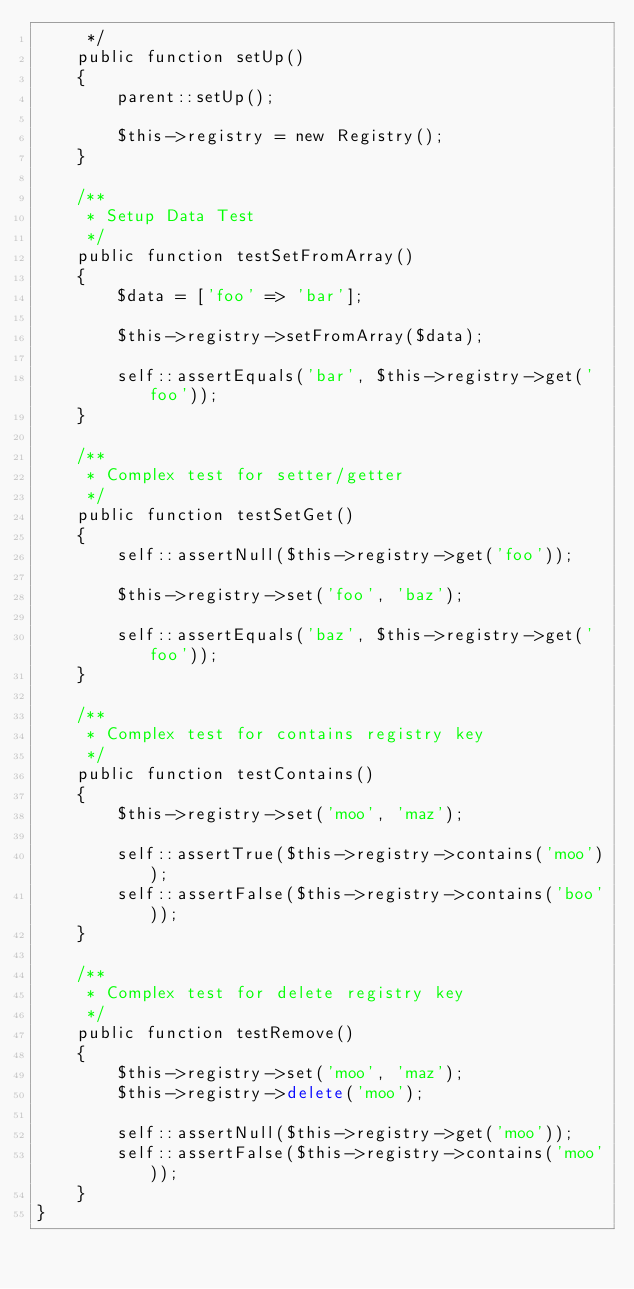Convert code to text. <code><loc_0><loc_0><loc_500><loc_500><_PHP_>     */
    public function setUp()
    {
        parent::setUp();

        $this->registry = new Registry();
    }

    /**
     * Setup Data Test
     */
    public function testSetFromArray()
    {
        $data = ['foo' => 'bar'];

        $this->registry->setFromArray($data);

        self::assertEquals('bar', $this->registry->get('foo'));
    }

    /**
     * Complex test for setter/getter
     */
    public function testSetGet()
    {
        self::assertNull($this->registry->get('foo'));

        $this->registry->set('foo', 'baz');

        self::assertEquals('baz', $this->registry->get('foo'));
    }

    /**
     * Complex test for contains registry key
     */
    public function testContains()
    {
        $this->registry->set('moo', 'maz');

        self::assertTrue($this->registry->contains('moo'));
        self::assertFalse($this->registry->contains('boo'));
    }

    /**
     * Complex test for delete registry key
     */
    public function testRemove()
    {
        $this->registry->set('moo', 'maz');
        $this->registry->delete('moo');

        self::assertNull($this->registry->get('moo'));
        self::assertFalse($this->registry->contains('moo'));
    }
}
</code> 